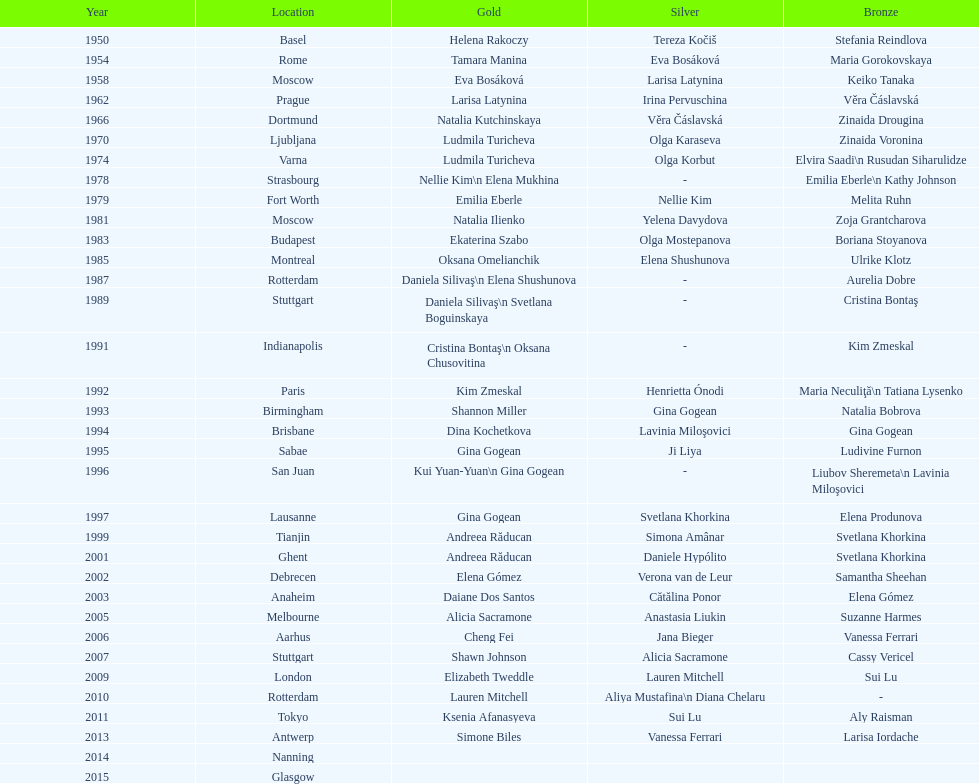Which pair of american competitors secured back-to-back floor exercise gold medals in the 1992 and 1993 artistic gymnastics world championships? Kim Zmeskal, Shannon Miller. 